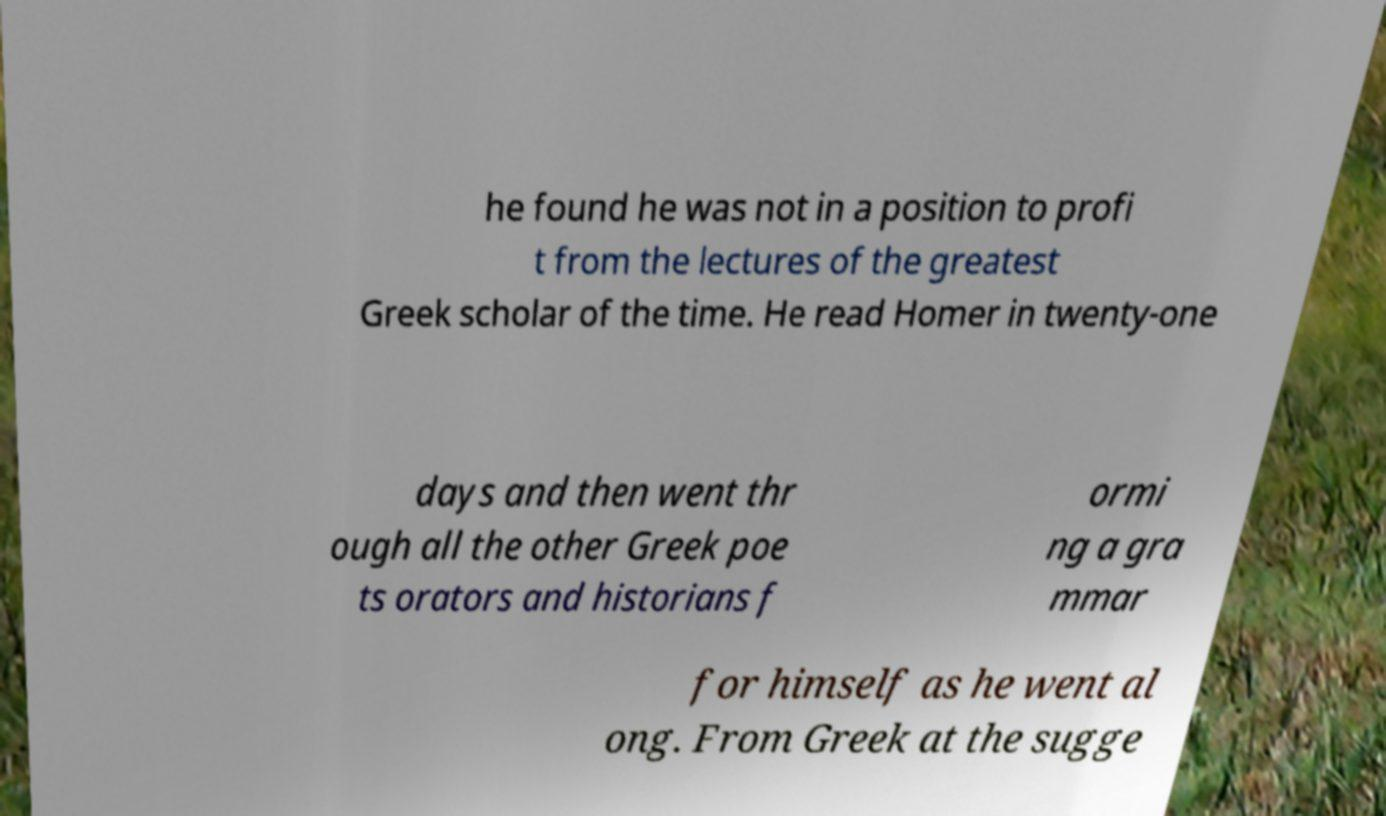Could you extract and type out the text from this image? he found he was not in a position to profi t from the lectures of the greatest Greek scholar of the time. He read Homer in twenty-one days and then went thr ough all the other Greek poe ts orators and historians f ormi ng a gra mmar for himself as he went al ong. From Greek at the sugge 